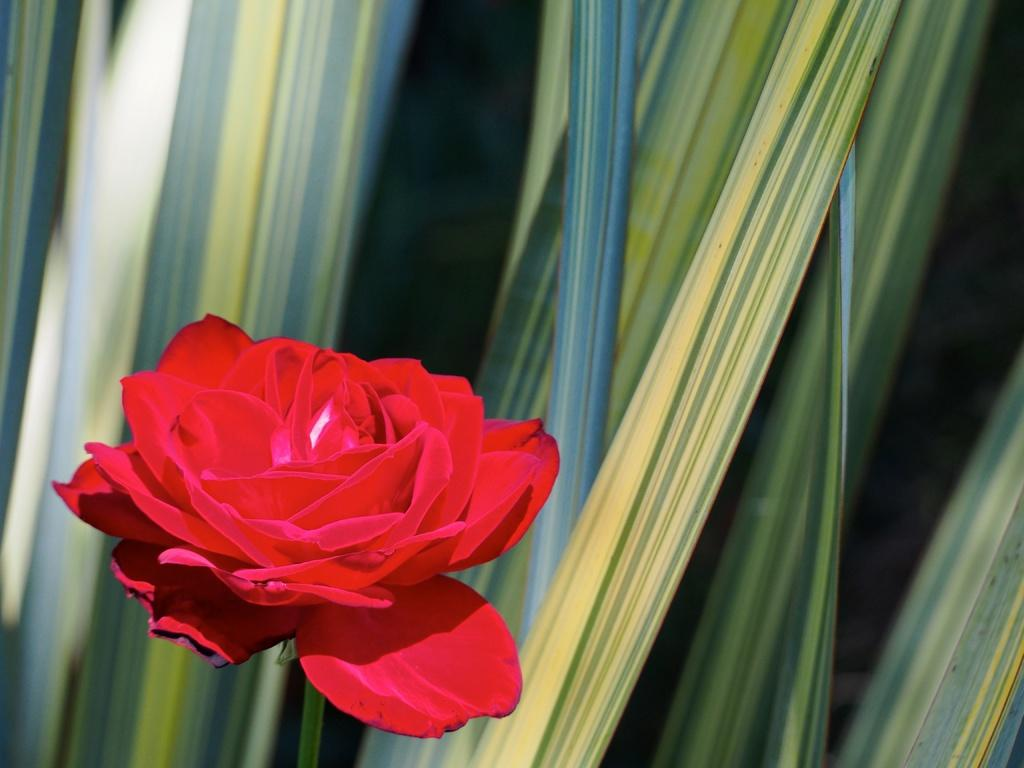What type of plant can be seen in the image? There is a flower plant in the image. What type of berry can be heard in the image? There is no berry present in the image, and therefore no sound can be heard from it. 